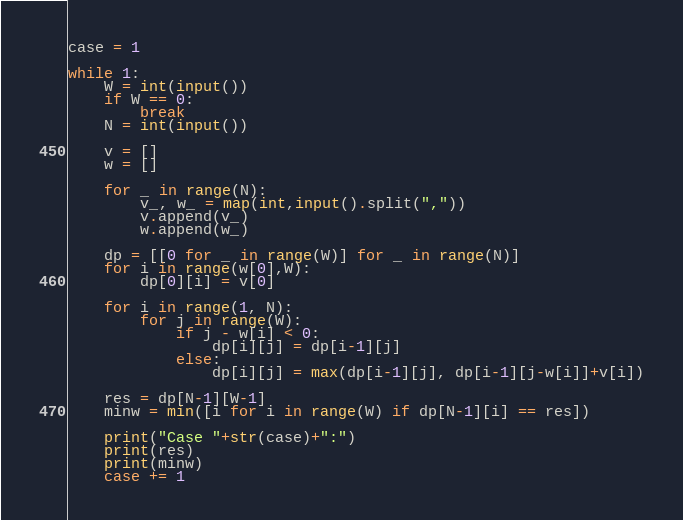Convert code to text. <code><loc_0><loc_0><loc_500><loc_500><_Python_>case = 1

while 1:
	W = int(input())
	if W == 0:
		break
	N = int(input())

	v = []
	w = []

	for _ in range(N):
		v_, w_ = map(int,input().split(","))
		v.append(v_)
		w.append(w_)

	dp = [[0 for _ in range(W)] for _ in range(N)]
	for i in range(w[0],W):
		dp[0][i] = v[0]

	for i in range(1, N):
		for j in range(W):
			if j - w[i] < 0:
				dp[i][j] = dp[i-1][j]
			else:
				dp[i][j] = max(dp[i-1][j], dp[i-1][j-w[i]]+v[i])

	res = dp[N-1][W-1]
	minw = min([i for i in range(W) if dp[N-1][i] == res])

	print("Case "+str(case)+":")
	print(res)
	print(minw)
	case += 1</code> 